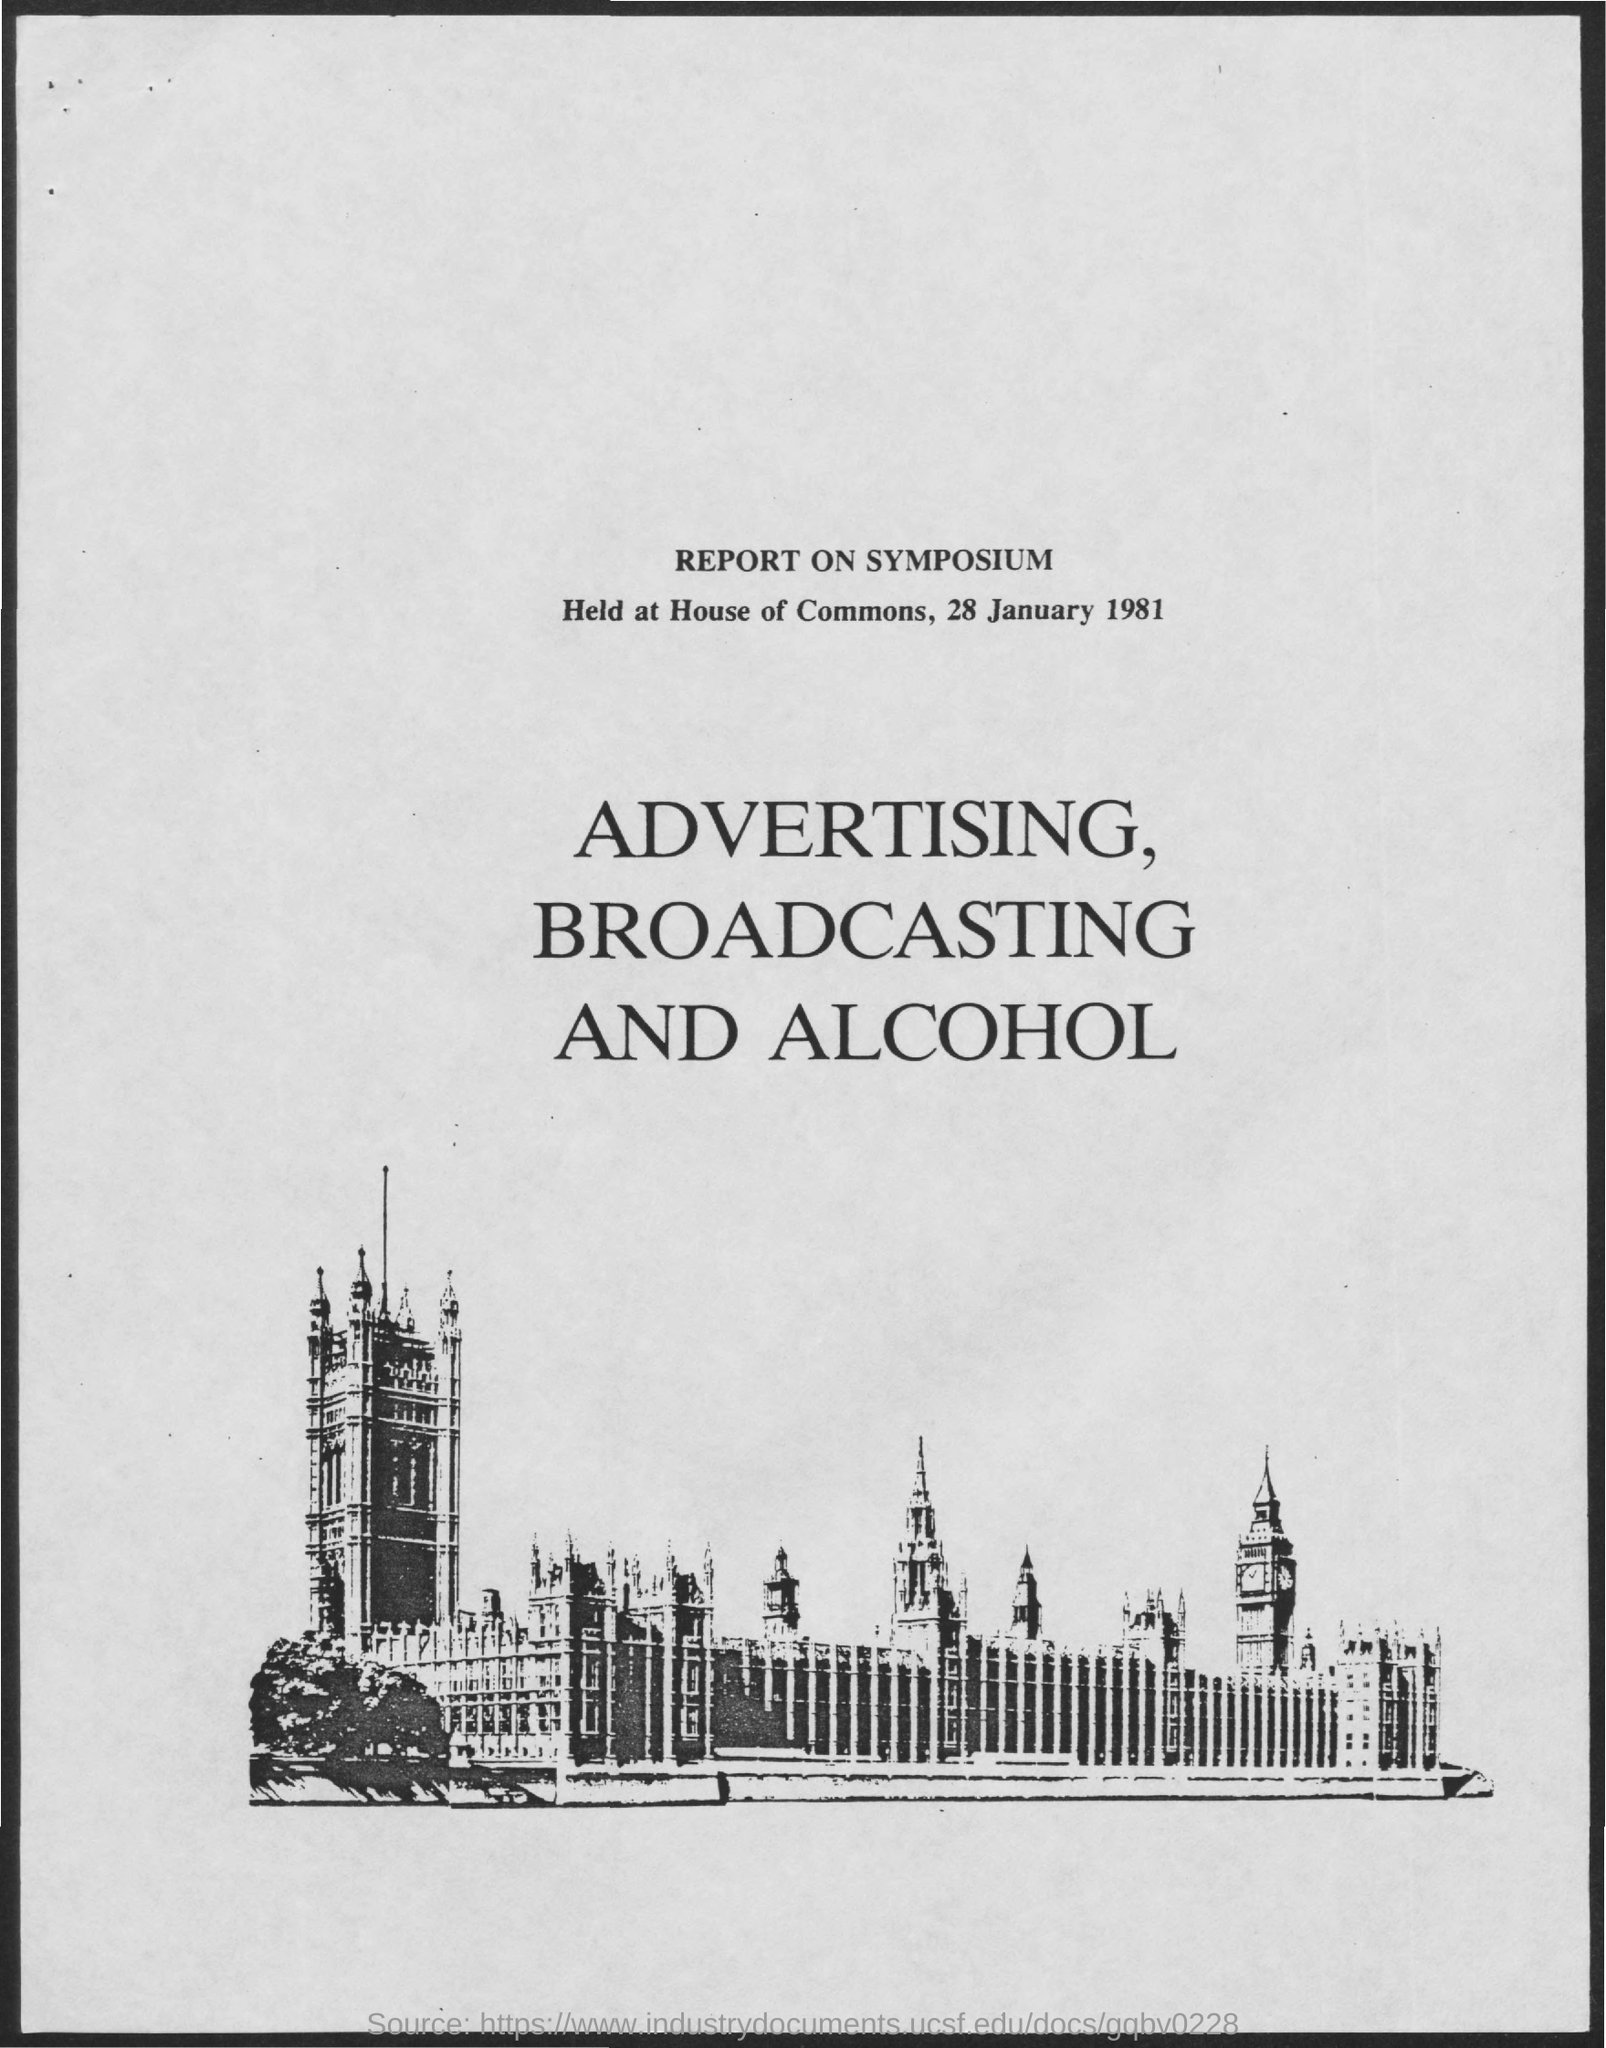Specify some key components in this picture. The topic of advertising, broadcasting, and alcohol is... The Symposium was held on 28 January 1981. The report concerns a symposium. The Symposium was held at the house of commons. 